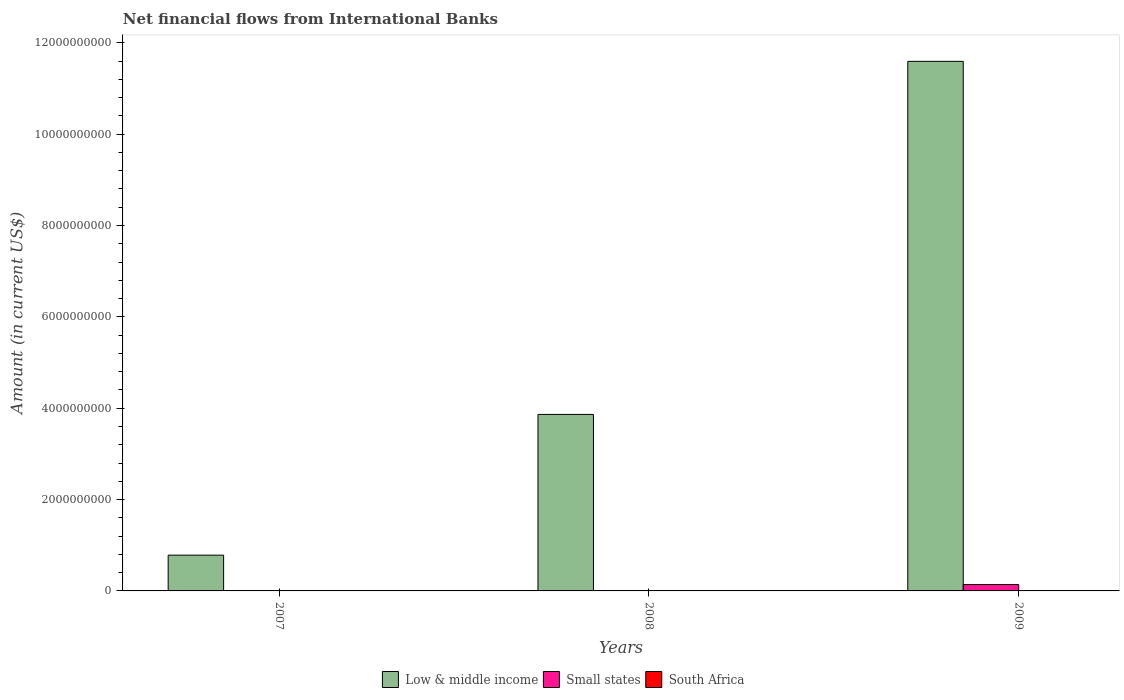Are the number of bars per tick equal to the number of legend labels?
Keep it short and to the point. No. How many bars are there on the 1st tick from the left?
Give a very brief answer. 1. In how many cases, is the number of bars for a given year not equal to the number of legend labels?
Keep it short and to the point. 3. What is the net financial aid flows in Small states in 2007?
Give a very brief answer. 0. Across all years, what is the maximum net financial aid flows in Low & middle income?
Ensure brevity in your answer.  1.16e+1. Across all years, what is the minimum net financial aid flows in Small states?
Offer a very short reply. 0. In which year was the net financial aid flows in Small states maximum?
Provide a short and direct response. 2009. What is the difference between the net financial aid flows in Low & middle income in 2008 and that in 2009?
Provide a succinct answer. -7.73e+09. What is the difference between the net financial aid flows in South Africa in 2007 and the net financial aid flows in Low & middle income in 2009?
Provide a succinct answer. -1.16e+1. In the year 2009, what is the difference between the net financial aid flows in Small states and net financial aid flows in Low & middle income?
Make the answer very short. -1.15e+1. In how many years, is the net financial aid flows in Low & middle income greater than 2400000000 US$?
Make the answer very short. 2. What is the ratio of the net financial aid flows in Low & middle income in 2008 to that in 2009?
Provide a short and direct response. 0.33. What is the difference between the highest and the second highest net financial aid flows in Low & middle income?
Provide a short and direct response. 7.73e+09. What is the difference between the highest and the lowest net financial aid flows in Low & middle income?
Your answer should be very brief. 1.08e+1. Is the sum of the net financial aid flows in Low & middle income in 2008 and 2009 greater than the maximum net financial aid flows in Small states across all years?
Ensure brevity in your answer.  Yes. Is it the case that in every year, the sum of the net financial aid flows in Low & middle income and net financial aid flows in South Africa is greater than the net financial aid flows in Small states?
Provide a short and direct response. Yes. Are all the bars in the graph horizontal?
Make the answer very short. No. How many years are there in the graph?
Your response must be concise. 3. Are the values on the major ticks of Y-axis written in scientific E-notation?
Your answer should be very brief. No. Does the graph contain any zero values?
Your response must be concise. Yes. Does the graph contain grids?
Provide a short and direct response. No. What is the title of the graph?
Your answer should be compact. Net financial flows from International Banks. Does "Brunei Darussalam" appear as one of the legend labels in the graph?
Provide a succinct answer. No. What is the label or title of the Y-axis?
Provide a succinct answer. Amount (in current US$). What is the Amount (in current US$) in Low & middle income in 2007?
Keep it short and to the point. 7.83e+08. What is the Amount (in current US$) of Low & middle income in 2008?
Ensure brevity in your answer.  3.86e+09. What is the Amount (in current US$) of Small states in 2008?
Ensure brevity in your answer.  0. What is the Amount (in current US$) of Low & middle income in 2009?
Offer a very short reply. 1.16e+1. What is the Amount (in current US$) of Small states in 2009?
Your response must be concise. 1.39e+08. What is the Amount (in current US$) in South Africa in 2009?
Provide a succinct answer. 0. Across all years, what is the maximum Amount (in current US$) of Low & middle income?
Keep it short and to the point. 1.16e+1. Across all years, what is the maximum Amount (in current US$) of Small states?
Provide a succinct answer. 1.39e+08. Across all years, what is the minimum Amount (in current US$) in Low & middle income?
Your answer should be compact. 7.83e+08. What is the total Amount (in current US$) of Low & middle income in the graph?
Provide a short and direct response. 1.62e+1. What is the total Amount (in current US$) of Small states in the graph?
Your response must be concise. 1.39e+08. What is the difference between the Amount (in current US$) of Low & middle income in 2007 and that in 2008?
Ensure brevity in your answer.  -3.08e+09. What is the difference between the Amount (in current US$) in Low & middle income in 2007 and that in 2009?
Your answer should be compact. -1.08e+1. What is the difference between the Amount (in current US$) of Low & middle income in 2008 and that in 2009?
Provide a short and direct response. -7.73e+09. What is the difference between the Amount (in current US$) in Low & middle income in 2007 and the Amount (in current US$) in Small states in 2009?
Ensure brevity in your answer.  6.44e+08. What is the difference between the Amount (in current US$) in Low & middle income in 2008 and the Amount (in current US$) in Small states in 2009?
Keep it short and to the point. 3.72e+09. What is the average Amount (in current US$) of Low & middle income per year?
Ensure brevity in your answer.  5.41e+09. What is the average Amount (in current US$) in Small states per year?
Your answer should be very brief. 4.65e+07. In the year 2009, what is the difference between the Amount (in current US$) of Low & middle income and Amount (in current US$) of Small states?
Your answer should be compact. 1.15e+1. What is the ratio of the Amount (in current US$) in Low & middle income in 2007 to that in 2008?
Your answer should be compact. 0.2. What is the ratio of the Amount (in current US$) in Low & middle income in 2007 to that in 2009?
Your answer should be compact. 0.07. What is the ratio of the Amount (in current US$) of Low & middle income in 2008 to that in 2009?
Your response must be concise. 0.33. What is the difference between the highest and the second highest Amount (in current US$) of Low & middle income?
Your answer should be very brief. 7.73e+09. What is the difference between the highest and the lowest Amount (in current US$) in Low & middle income?
Provide a succinct answer. 1.08e+1. What is the difference between the highest and the lowest Amount (in current US$) of Small states?
Keep it short and to the point. 1.39e+08. 